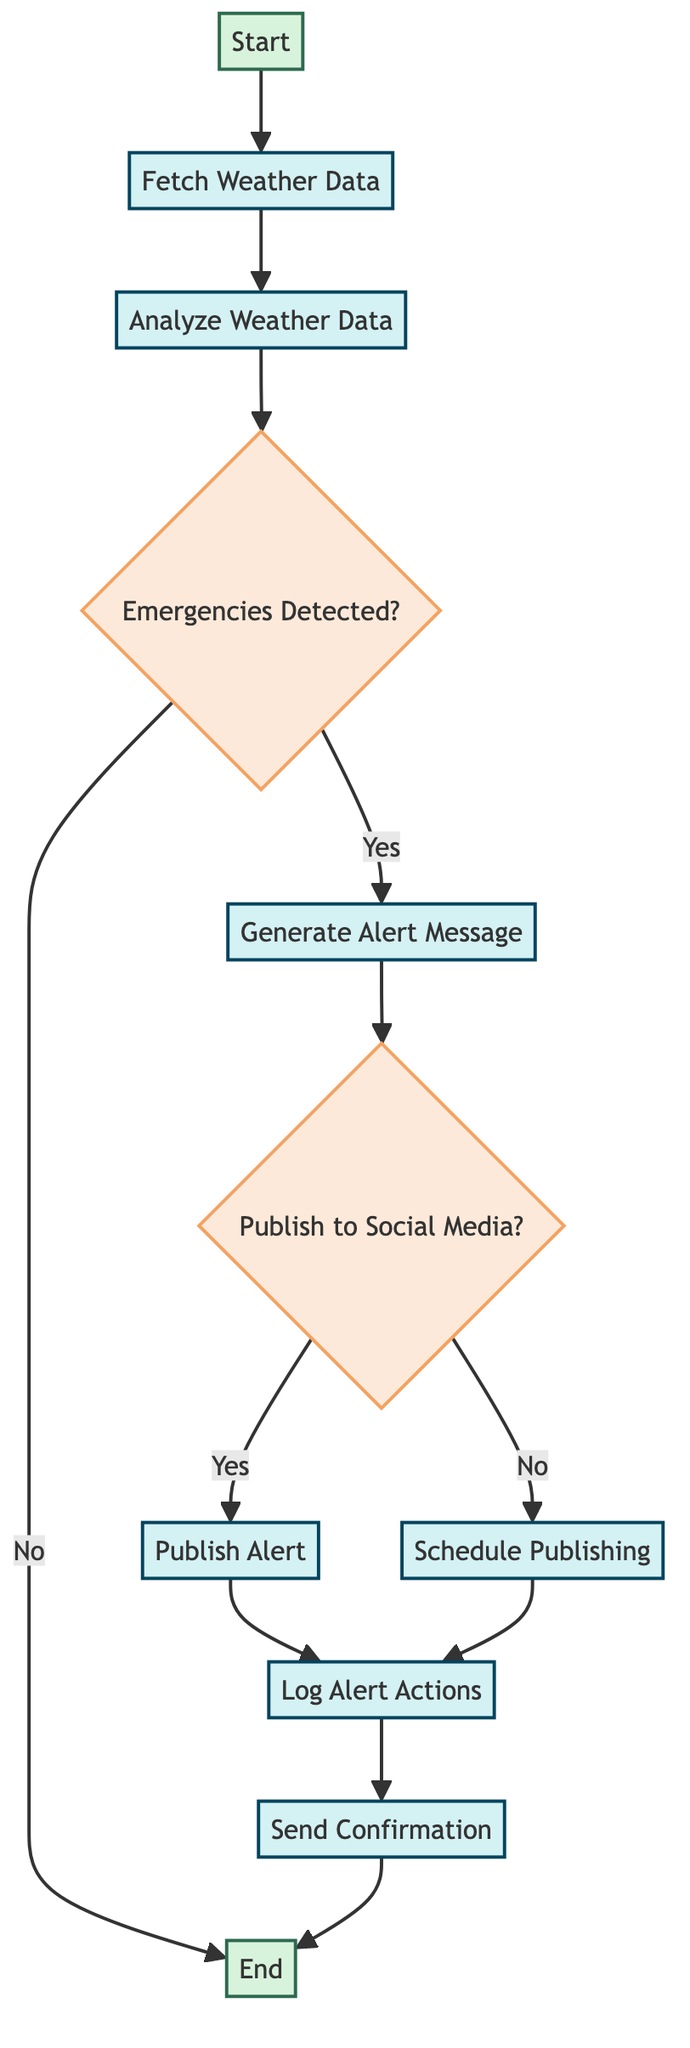What is the starting node of the flowchart? The first node in the flowchart is labeled "Start," indicating the beginning of the weather alert notification function.
Answer: Start How many decision nodes are in the flowchart? There are two decision nodes: "Emergencies Detected?" and "Publish to Social Media?" which are used to determine the flow of the process.
Answer: 2 What follows after analyzing the weather data? After "Analyze Weather Data," the next step is to check if emergencies are detected, represented by the decision node "Emergencies Detected?".
Answer: Emergencies Detected? What message is generated after an emergency is detected? If an emergency is detected ("Yes" branch), the flow continues to "Generate Alert Message," where the alert message is created.
Answer: Generate Alert Message What action is taken if the alert message is to be scheduled? If the decision is made to not publish immediately ("No" branch), the flow goes to "Schedule Publishing," indicating the message will be scheduled for a later time.
Answer: Schedule Publishing Which process comes before sending a confirmation? Before "Send Confirmation," the process "Log Alert Actions" takes place, ensuring all actions are recorded for accountability.
Answer: Log Alert Actions What happens if no emergencies are detected? If no emergencies are detected, the flowchart leads directly to the "End" node, terminating the process without further actions.
Answer: End What is the outcome after publishing the alert? After "Publish Alert," the next action is to "Log Alert Actions," indicating that publishing has been completed and needs to be logged.
Answer: Log Alert Actions What type of data is fetched initially? Initially, the function fetches "Current weather data" from a reliable API such as OpenWeatherMap to assess weather conditions.
Answer: Weather data 